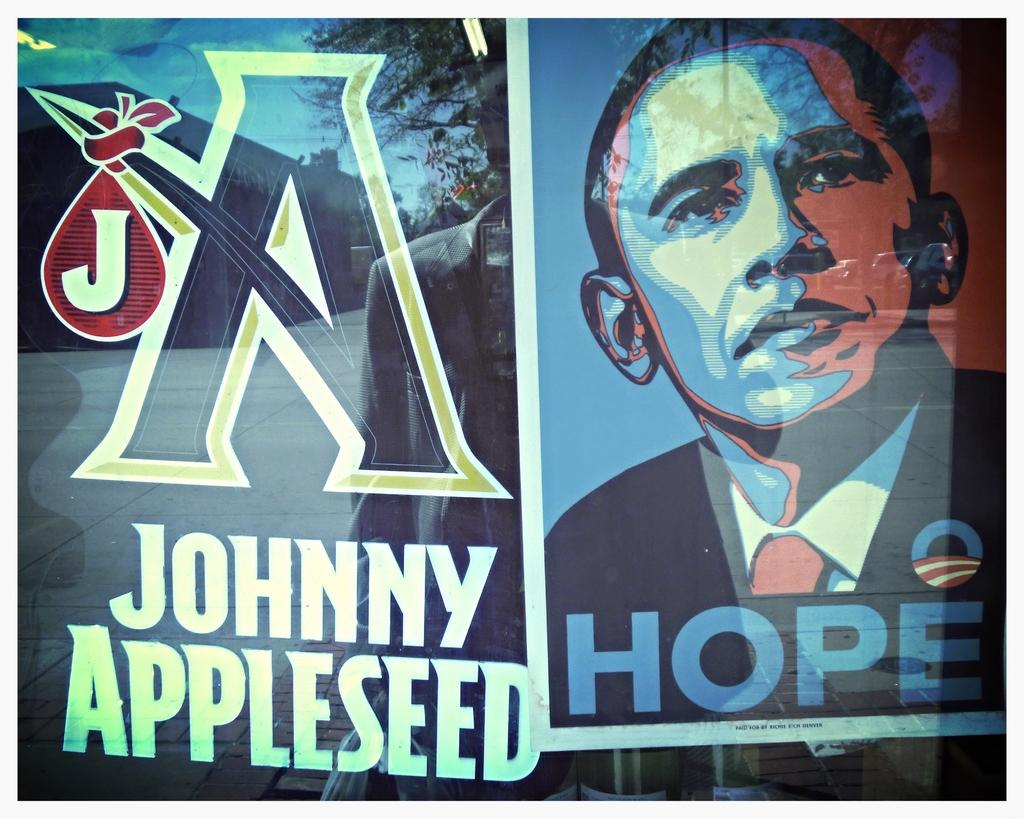Provide a one-sentence caption for the provided image. A sign for Johnny appleseed that has a picture of Obama that says Hope. 